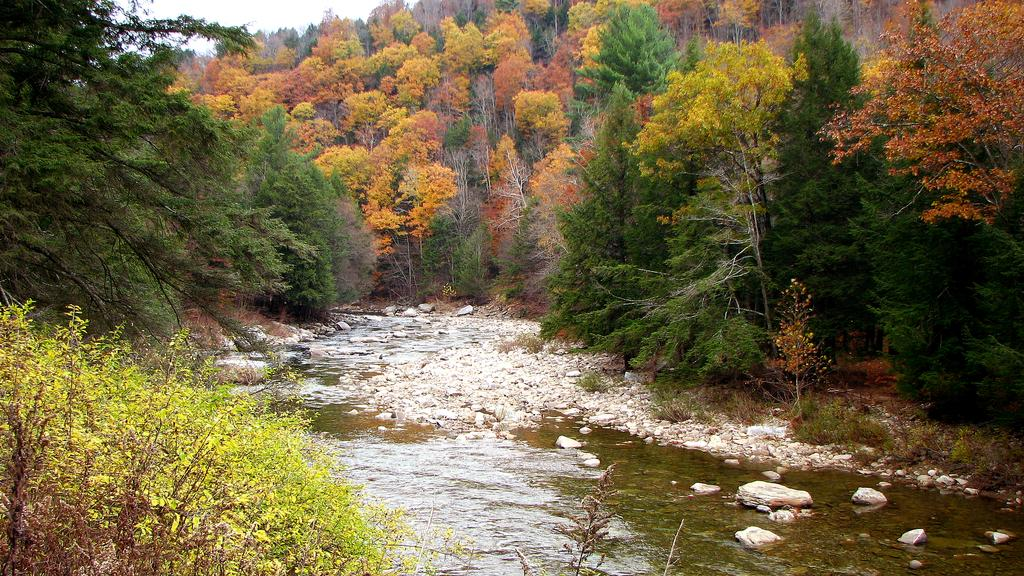What body of water is present in the image? There is a lake in the image. What can be found within the lake? There are rocks in the lake. What type of vegetation is visible in the background of the image? There is a group of trees in the background of the image. What else can be seen in the background of the image? The sky is visible in the background of the image. What type of fruit is being used as a route across the lake in the image? There is no fruit or route present in the image; it features a lake with rocks and a background of trees and sky. 